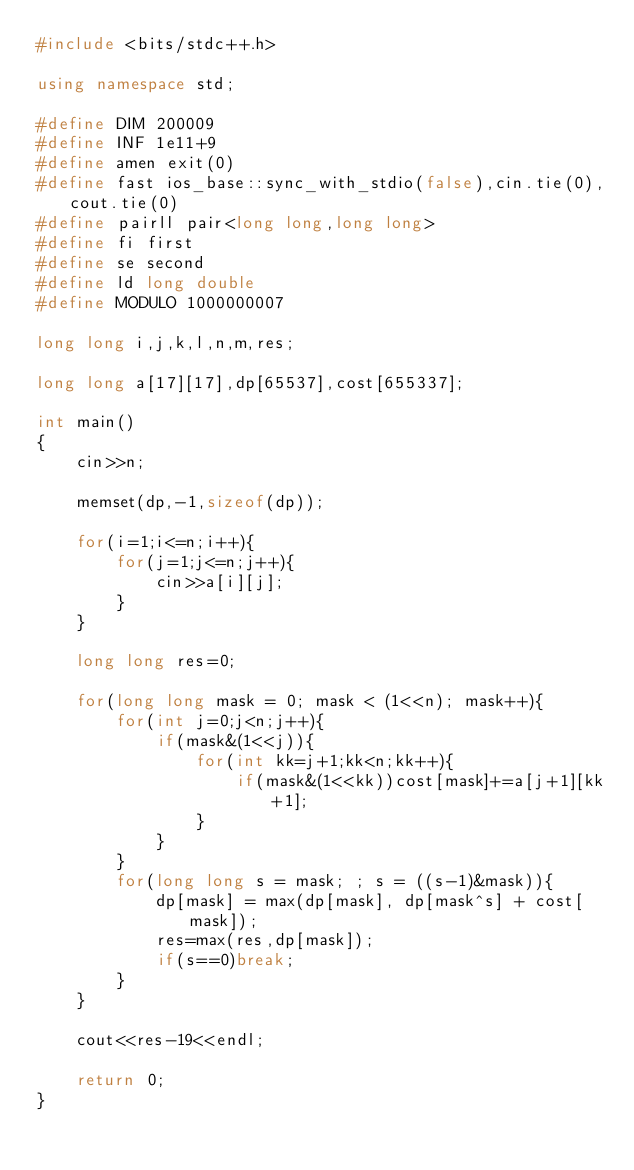Convert code to text. <code><loc_0><loc_0><loc_500><loc_500><_C++_>#include <bits/stdc++.h>

using namespace std;

#define DIM 200009
#define INF 1e11+9
#define amen exit(0)
#define fast ios_base::sync_with_stdio(false),cin.tie(0),cout.tie(0)
#define pairll pair<long long,long long>
#define fi first
#define se second
#define ld long double
#define MODULO 1000000007

long long i,j,k,l,n,m,res;

long long a[17][17],dp[65537],cost[655337];

int main()
{
    cin>>n;

    memset(dp,-1,sizeof(dp));

    for(i=1;i<=n;i++){
        for(j=1;j<=n;j++){
            cin>>a[i][j];
        }
    }

    long long res=0;

    for(long long mask = 0; mask < (1<<n); mask++){
        for(int j=0;j<n;j++){
            if(mask&(1<<j)){
                for(int kk=j+1;kk<n;kk++){
                    if(mask&(1<<kk))cost[mask]+=a[j+1][kk+1];
                }
            }
        }
        for(long long s = mask; ; s = ((s-1)&mask)){
            dp[mask] = max(dp[mask], dp[mask^s] + cost[mask]);
            res=max(res,dp[mask]);
            if(s==0)break;
        }
    }

    cout<<res-19<<endl;

    return 0;
}
</code> 